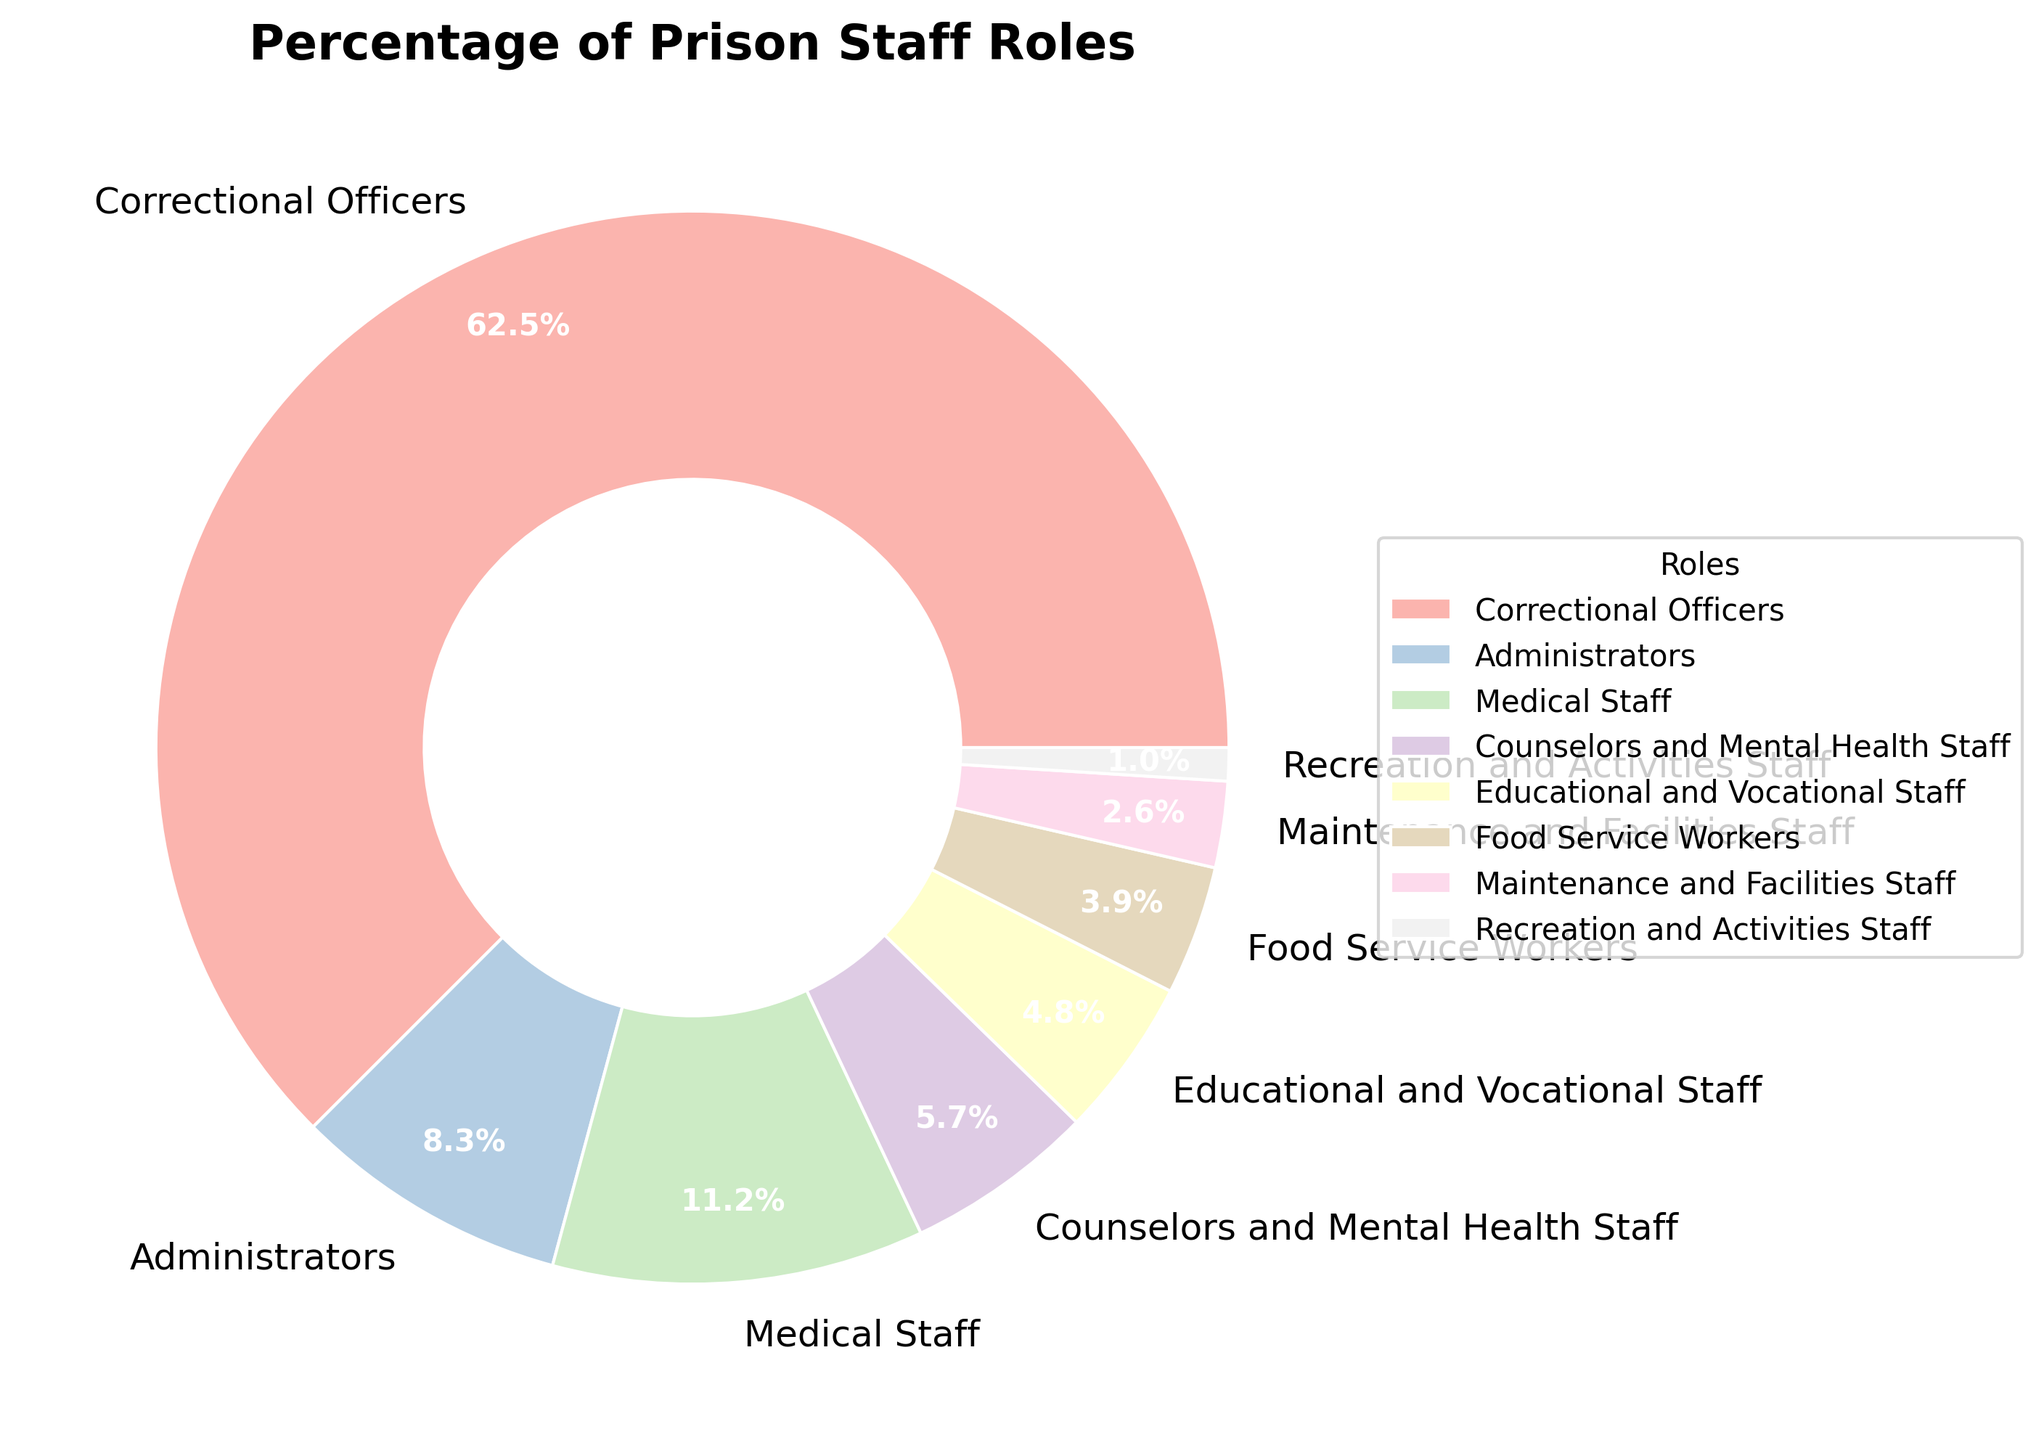What role has the largest percentage of prison staff? The role with the largest percentage is identified visually as the portion of the pie chart that takes up the most space.
Answer: Correctional Officers Which two roles combined almost equal the total percentage of Correctional Officers? Correctional Officers make up 62.5%. Adding Administrators (8.3%) and Medical Staff (11.2%) gives 19.5%. Adding Counselors and Mental Health Staff (5.7%), then Educational and Vocational Staff (4.8%), Food Service Workers (3.9%), Maintenance and Facilities Staff (2.6%), and Recreation and Activities Staff (1.0%) gives in total 27.8%. Administrators (8.3%) + Medical Staff (11.2%) + Counselors and Mental Health Staff (5.7%) gives 25.2%. Administrators (8.3%) + Medical Staff (11.2%) + Educational and Vocational Staff (4.8%) gives 24.3%. Administrators (8.3%) + Medical Staff (11.2%) + Food Service Workers (3.9%) gives 23.4%. Overall, no two roles combined equal to 62.5%. Therefore, Correctional Officers have the largest percentage.
Answer: No two roles combined equal 62.5% Is the percentage of Correctional Officers more than five times that of Educational and Vocational Staff? Correctional Officers constitute 62.5%, and Educational and Vocational Staff constitute 4.8%. Five times 4.8% is 24% (5 * 4.8 = 24). 62.5% is indeed more than 24%.
Answer: Yes What is the combined percentage of Food Service Workers and Maintenance and Facilities Staff? Food Service Workers make up 3.9%, and Maintenance and Facilities Staff make up 2.6%. Adding these values together, 3.9% + 2.6% = 6.5%.
Answer: 6.5% Are there any roles that make up less than 2% of the staff? If so, which one(s)? Roles that make up less than 2% can be identified by their segments in the pie chart being smaller than others or by their listed percentages. Recreation and Activities Staff constitute 1.0%, which is less than 2%.
Answer: Recreation and Activities Staff How does the percentage of Medical Staff compare to the percentage of Counselors and Mental Health Staff? Medical Staff constitute 11.2%, and Counselors and Mental Health Staff constitute 5.7%. Comparing these values, 11.2% is greater than 5.7%.
Answer: Medical Staff is greater What is the difference between the role with the highest percentage and the role with the lowest percentage? The role with the highest percentage is Correctional Officers (62.5%) and the role with the lowest percentage is Recreation and Activities Staff (1.0%). The difference is calculated as 62.5% - 1.0% = 61.5%.
Answer: 61.5% How many staff roles have a percentage greater than 10%? By inspecting the percentages on the pie chart, Correctional Officers (62.5%) and Medical Staff (11.2%) are the only roles greater than 10%. Thus, there are 2 roles.
Answer: 2 